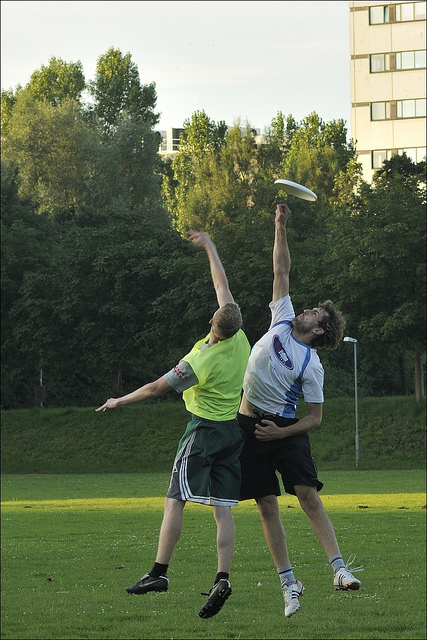<image>Which male is ready to hit a tennis ball with a racket? It is ambiguous to identify which male is ready to hit a tennis ball with a racket. It could be the male on the right. Which male is ready to hit a tennis ball with a racket? I don't know which male is ready to hit a tennis ball with a racket. None of them are indicated as ready or holding a racket. 